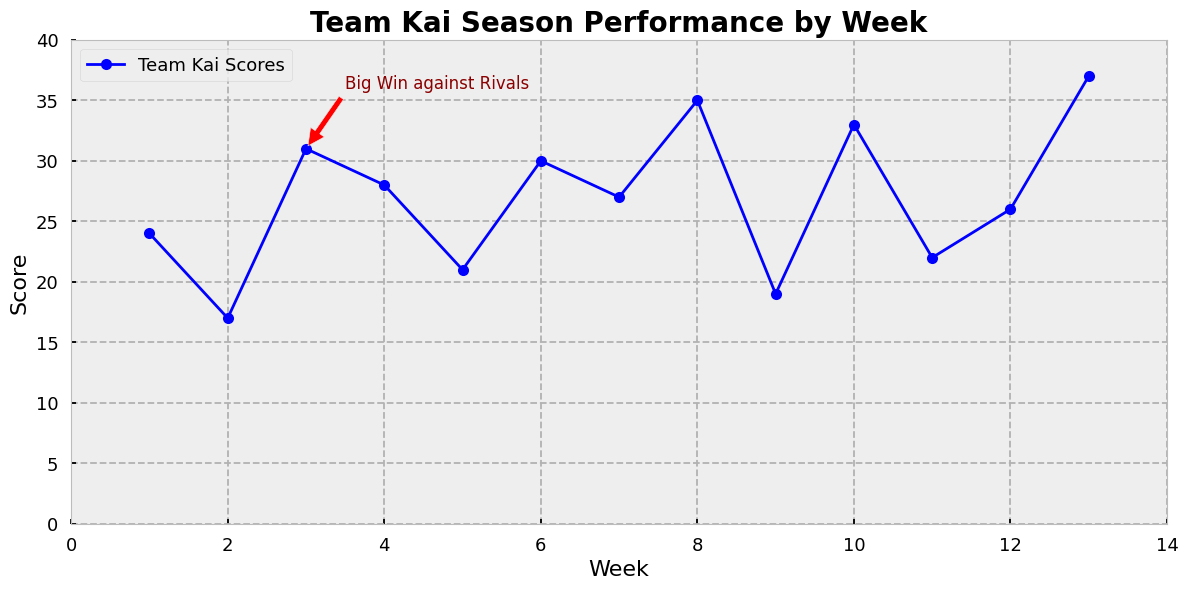How many games did Team Kai score more than 30 points in? To determine this, look at the line chart and count how many times the team's score exceeds 30. From the data, these scores are at Weeks 3, 6, 8, 10, and 13, making it a total of 5 instances.
Answer: 5 What was the score difference between Week 3 and Week 4? Refer to the line chart: the score at Week 3 was 31, and at Week 4 it was 28. The difference is 31 - 28 = 3 points.
Answer: 3 Which week shows the highest score for Team Kai? By observing the highest point on the line chart, we see that Week 13 has the highest score of 37.
Answer: Week 13 What are the scores for the weeks that have annotations? Find the annotated point on the line chart, which indicates "Big Win against Rivals" at Week 3, and its corresponding score is 31.
Answer: 31 How does the score in Week 9 compare to the score in Week 12? Check the chart to see Week 9 has a score of 19 and Week 12 has a score of 26. Week 12's score of 26 is higher than Week 9's score of 19.
Answer: Week 12's score is higher What is the average score across the first 5 weeks? Add the scores from Week 1 to Week 5: 24 + 17 + 31 + 28 + 21 = 121. Then divide by the number of weeks, 121/5 = 24.2.
Answer: 24.2 Which week had the lowest score? Find the lowest point on the line chart, which occurs at Week 2 with a score of 17.
Answer: Week 2 How much did the score increase from Week 6 to Week 7? Check the scores for Week 6 (30) and Week 7 (27). The score actually decreased, with a difference of 30 - 27 = 3 points.
Answer: Decreased by 3 points 